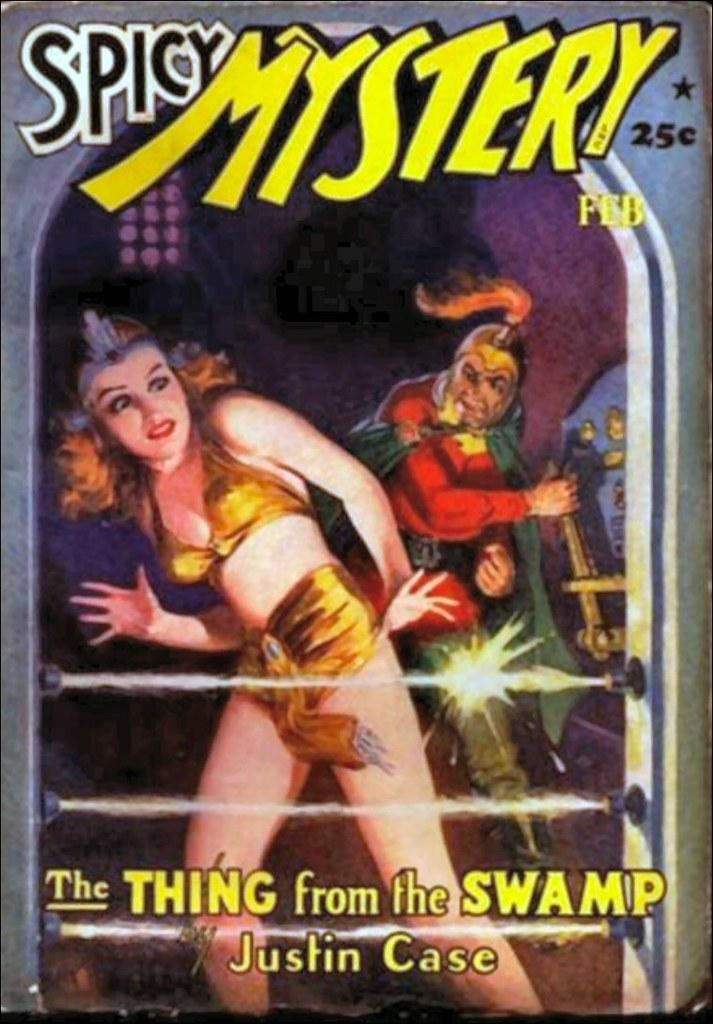What is present in the image that features a representation of people? There is a poster in the image that contains a depiction of people. What else can be found on the poster besides the depiction of people? The poster contains text. What type of wax is being used by the mother in the image? There is no mother or wax present in the image; it only features a poster with a depiction of people and text. 